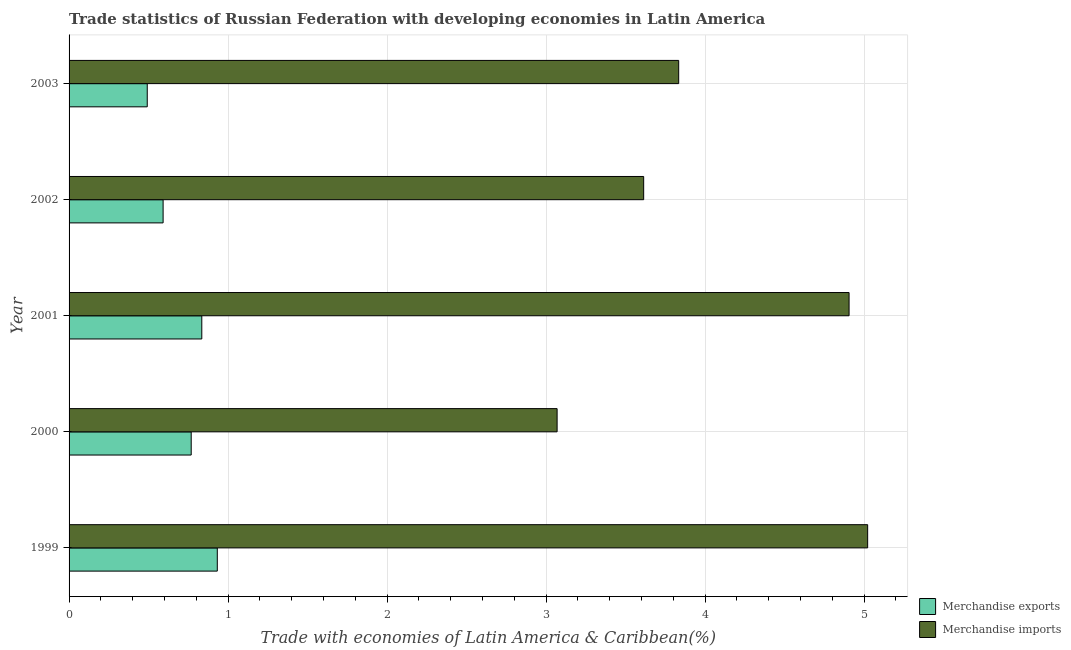How many different coloured bars are there?
Ensure brevity in your answer.  2. How many groups of bars are there?
Ensure brevity in your answer.  5. Are the number of bars per tick equal to the number of legend labels?
Offer a very short reply. Yes. How many bars are there on the 5th tick from the bottom?
Make the answer very short. 2. In how many cases, is the number of bars for a given year not equal to the number of legend labels?
Ensure brevity in your answer.  0. What is the merchandise exports in 2000?
Ensure brevity in your answer.  0.77. Across all years, what is the maximum merchandise imports?
Offer a terse response. 5.02. Across all years, what is the minimum merchandise exports?
Keep it short and to the point. 0.49. In which year was the merchandise exports maximum?
Your answer should be compact. 1999. What is the total merchandise exports in the graph?
Offer a terse response. 3.62. What is the difference between the merchandise imports in 1999 and that in 2003?
Give a very brief answer. 1.19. What is the difference between the merchandise imports in 1999 and the merchandise exports in 2003?
Keep it short and to the point. 4.53. What is the average merchandise exports per year?
Keep it short and to the point. 0.72. In the year 2000, what is the difference between the merchandise exports and merchandise imports?
Offer a terse response. -2.3. In how many years, is the merchandise exports greater than 2.6 %?
Keep it short and to the point. 0. What is the ratio of the merchandise imports in 2000 to that in 2003?
Offer a terse response. 0.8. Is the difference between the merchandise imports in 2000 and 2003 greater than the difference between the merchandise exports in 2000 and 2003?
Keep it short and to the point. No. What is the difference between the highest and the second highest merchandise imports?
Provide a succinct answer. 0.12. What is the difference between the highest and the lowest merchandise imports?
Your answer should be very brief. 1.95. In how many years, is the merchandise imports greater than the average merchandise imports taken over all years?
Your answer should be compact. 2. How many bars are there?
Your response must be concise. 10. Are the values on the major ticks of X-axis written in scientific E-notation?
Keep it short and to the point. No. Where does the legend appear in the graph?
Offer a very short reply. Bottom right. How many legend labels are there?
Provide a succinct answer. 2. How are the legend labels stacked?
Keep it short and to the point. Vertical. What is the title of the graph?
Give a very brief answer. Trade statistics of Russian Federation with developing economies in Latin America. Does "Private credit bureau" appear as one of the legend labels in the graph?
Ensure brevity in your answer.  No. What is the label or title of the X-axis?
Your response must be concise. Trade with economies of Latin America & Caribbean(%). What is the Trade with economies of Latin America & Caribbean(%) of Merchandise exports in 1999?
Give a very brief answer. 0.93. What is the Trade with economies of Latin America & Caribbean(%) of Merchandise imports in 1999?
Make the answer very short. 5.02. What is the Trade with economies of Latin America & Caribbean(%) in Merchandise exports in 2000?
Offer a terse response. 0.77. What is the Trade with economies of Latin America & Caribbean(%) in Merchandise imports in 2000?
Your answer should be compact. 3.07. What is the Trade with economies of Latin America & Caribbean(%) in Merchandise exports in 2001?
Give a very brief answer. 0.83. What is the Trade with economies of Latin America & Caribbean(%) of Merchandise imports in 2001?
Your answer should be very brief. 4.91. What is the Trade with economies of Latin America & Caribbean(%) in Merchandise exports in 2002?
Make the answer very short. 0.59. What is the Trade with economies of Latin America & Caribbean(%) in Merchandise imports in 2002?
Ensure brevity in your answer.  3.61. What is the Trade with economies of Latin America & Caribbean(%) in Merchandise exports in 2003?
Your answer should be very brief. 0.49. What is the Trade with economies of Latin America & Caribbean(%) in Merchandise imports in 2003?
Ensure brevity in your answer.  3.83. Across all years, what is the maximum Trade with economies of Latin America & Caribbean(%) of Merchandise exports?
Give a very brief answer. 0.93. Across all years, what is the maximum Trade with economies of Latin America & Caribbean(%) in Merchandise imports?
Ensure brevity in your answer.  5.02. Across all years, what is the minimum Trade with economies of Latin America & Caribbean(%) in Merchandise exports?
Offer a very short reply. 0.49. Across all years, what is the minimum Trade with economies of Latin America & Caribbean(%) of Merchandise imports?
Your answer should be very brief. 3.07. What is the total Trade with economies of Latin America & Caribbean(%) of Merchandise exports in the graph?
Provide a short and direct response. 3.62. What is the total Trade with economies of Latin America & Caribbean(%) of Merchandise imports in the graph?
Your response must be concise. 20.45. What is the difference between the Trade with economies of Latin America & Caribbean(%) of Merchandise exports in 1999 and that in 2000?
Your answer should be compact. 0.16. What is the difference between the Trade with economies of Latin America & Caribbean(%) of Merchandise imports in 1999 and that in 2000?
Ensure brevity in your answer.  1.95. What is the difference between the Trade with economies of Latin America & Caribbean(%) in Merchandise exports in 1999 and that in 2001?
Provide a succinct answer. 0.1. What is the difference between the Trade with economies of Latin America & Caribbean(%) in Merchandise imports in 1999 and that in 2001?
Offer a very short reply. 0.12. What is the difference between the Trade with economies of Latin America & Caribbean(%) of Merchandise exports in 1999 and that in 2002?
Ensure brevity in your answer.  0.34. What is the difference between the Trade with economies of Latin America & Caribbean(%) of Merchandise imports in 1999 and that in 2002?
Keep it short and to the point. 1.41. What is the difference between the Trade with economies of Latin America & Caribbean(%) in Merchandise exports in 1999 and that in 2003?
Provide a succinct answer. 0.44. What is the difference between the Trade with economies of Latin America & Caribbean(%) of Merchandise imports in 1999 and that in 2003?
Offer a very short reply. 1.19. What is the difference between the Trade with economies of Latin America & Caribbean(%) of Merchandise exports in 2000 and that in 2001?
Make the answer very short. -0.07. What is the difference between the Trade with economies of Latin America & Caribbean(%) in Merchandise imports in 2000 and that in 2001?
Your response must be concise. -1.84. What is the difference between the Trade with economies of Latin America & Caribbean(%) in Merchandise exports in 2000 and that in 2002?
Offer a very short reply. 0.18. What is the difference between the Trade with economies of Latin America & Caribbean(%) of Merchandise imports in 2000 and that in 2002?
Keep it short and to the point. -0.54. What is the difference between the Trade with economies of Latin America & Caribbean(%) of Merchandise exports in 2000 and that in 2003?
Your response must be concise. 0.28. What is the difference between the Trade with economies of Latin America & Caribbean(%) in Merchandise imports in 2000 and that in 2003?
Your response must be concise. -0.76. What is the difference between the Trade with economies of Latin America & Caribbean(%) in Merchandise exports in 2001 and that in 2002?
Ensure brevity in your answer.  0.24. What is the difference between the Trade with economies of Latin America & Caribbean(%) of Merchandise imports in 2001 and that in 2002?
Your answer should be compact. 1.29. What is the difference between the Trade with economies of Latin America & Caribbean(%) of Merchandise exports in 2001 and that in 2003?
Offer a very short reply. 0.34. What is the difference between the Trade with economies of Latin America & Caribbean(%) in Merchandise imports in 2001 and that in 2003?
Offer a very short reply. 1.07. What is the difference between the Trade with economies of Latin America & Caribbean(%) in Merchandise exports in 2002 and that in 2003?
Keep it short and to the point. 0.1. What is the difference between the Trade with economies of Latin America & Caribbean(%) in Merchandise imports in 2002 and that in 2003?
Your answer should be compact. -0.22. What is the difference between the Trade with economies of Latin America & Caribbean(%) of Merchandise exports in 1999 and the Trade with economies of Latin America & Caribbean(%) of Merchandise imports in 2000?
Ensure brevity in your answer.  -2.14. What is the difference between the Trade with economies of Latin America & Caribbean(%) of Merchandise exports in 1999 and the Trade with economies of Latin America & Caribbean(%) of Merchandise imports in 2001?
Provide a short and direct response. -3.97. What is the difference between the Trade with economies of Latin America & Caribbean(%) in Merchandise exports in 1999 and the Trade with economies of Latin America & Caribbean(%) in Merchandise imports in 2002?
Your answer should be very brief. -2.68. What is the difference between the Trade with economies of Latin America & Caribbean(%) of Merchandise exports in 1999 and the Trade with economies of Latin America & Caribbean(%) of Merchandise imports in 2003?
Provide a short and direct response. -2.9. What is the difference between the Trade with economies of Latin America & Caribbean(%) of Merchandise exports in 2000 and the Trade with economies of Latin America & Caribbean(%) of Merchandise imports in 2001?
Give a very brief answer. -4.14. What is the difference between the Trade with economies of Latin America & Caribbean(%) in Merchandise exports in 2000 and the Trade with economies of Latin America & Caribbean(%) in Merchandise imports in 2002?
Your answer should be very brief. -2.85. What is the difference between the Trade with economies of Latin America & Caribbean(%) of Merchandise exports in 2000 and the Trade with economies of Latin America & Caribbean(%) of Merchandise imports in 2003?
Ensure brevity in your answer.  -3.07. What is the difference between the Trade with economies of Latin America & Caribbean(%) of Merchandise exports in 2001 and the Trade with economies of Latin America & Caribbean(%) of Merchandise imports in 2002?
Make the answer very short. -2.78. What is the difference between the Trade with economies of Latin America & Caribbean(%) in Merchandise exports in 2001 and the Trade with economies of Latin America & Caribbean(%) in Merchandise imports in 2003?
Offer a very short reply. -3. What is the difference between the Trade with economies of Latin America & Caribbean(%) of Merchandise exports in 2002 and the Trade with economies of Latin America & Caribbean(%) of Merchandise imports in 2003?
Provide a succinct answer. -3.24. What is the average Trade with economies of Latin America & Caribbean(%) of Merchandise exports per year?
Make the answer very short. 0.72. What is the average Trade with economies of Latin America & Caribbean(%) of Merchandise imports per year?
Keep it short and to the point. 4.09. In the year 1999, what is the difference between the Trade with economies of Latin America & Caribbean(%) in Merchandise exports and Trade with economies of Latin America & Caribbean(%) in Merchandise imports?
Provide a succinct answer. -4.09. In the year 2000, what is the difference between the Trade with economies of Latin America & Caribbean(%) in Merchandise exports and Trade with economies of Latin America & Caribbean(%) in Merchandise imports?
Ensure brevity in your answer.  -2.3. In the year 2001, what is the difference between the Trade with economies of Latin America & Caribbean(%) in Merchandise exports and Trade with economies of Latin America & Caribbean(%) in Merchandise imports?
Keep it short and to the point. -4.07. In the year 2002, what is the difference between the Trade with economies of Latin America & Caribbean(%) in Merchandise exports and Trade with economies of Latin America & Caribbean(%) in Merchandise imports?
Your answer should be very brief. -3.02. In the year 2003, what is the difference between the Trade with economies of Latin America & Caribbean(%) of Merchandise exports and Trade with economies of Latin America & Caribbean(%) of Merchandise imports?
Your answer should be very brief. -3.34. What is the ratio of the Trade with economies of Latin America & Caribbean(%) in Merchandise exports in 1999 to that in 2000?
Your response must be concise. 1.21. What is the ratio of the Trade with economies of Latin America & Caribbean(%) of Merchandise imports in 1999 to that in 2000?
Your answer should be very brief. 1.64. What is the ratio of the Trade with economies of Latin America & Caribbean(%) in Merchandise exports in 1999 to that in 2001?
Provide a succinct answer. 1.12. What is the ratio of the Trade with economies of Latin America & Caribbean(%) of Merchandise imports in 1999 to that in 2001?
Keep it short and to the point. 1.02. What is the ratio of the Trade with economies of Latin America & Caribbean(%) in Merchandise exports in 1999 to that in 2002?
Ensure brevity in your answer.  1.58. What is the ratio of the Trade with economies of Latin America & Caribbean(%) in Merchandise imports in 1999 to that in 2002?
Your response must be concise. 1.39. What is the ratio of the Trade with economies of Latin America & Caribbean(%) of Merchandise exports in 1999 to that in 2003?
Make the answer very short. 1.9. What is the ratio of the Trade with economies of Latin America & Caribbean(%) of Merchandise imports in 1999 to that in 2003?
Provide a succinct answer. 1.31. What is the ratio of the Trade with economies of Latin America & Caribbean(%) of Merchandise exports in 2000 to that in 2001?
Your answer should be compact. 0.92. What is the ratio of the Trade with economies of Latin America & Caribbean(%) of Merchandise imports in 2000 to that in 2001?
Your answer should be compact. 0.63. What is the ratio of the Trade with economies of Latin America & Caribbean(%) of Merchandise exports in 2000 to that in 2002?
Give a very brief answer. 1.3. What is the ratio of the Trade with economies of Latin America & Caribbean(%) in Merchandise imports in 2000 to that in 2002?
Your response must be concise. 0.85. What is the ratio of the Trade with economies of Latin America & Caribbean(%) of Merchandise exports in 2000 to that in 2003?
Your answer should be compact. 1.56. What is the ratio of the Trade with economies of Latin America & Caribbean(%) in Merchandise imports in 2000 to that in 2003?
Offer a very short reply. 0.8. What is the ratio of the Trade with economies of Latin America & Caribbean(%) in Merchandise exports in 2001 to that in 2002?
Provide a short and direct response. 1.41. What is the ratio of the Trade with economies of Latin America & Caribbean(%) of Merchandise imports in 2001 to that in 2002?
Make the answer very short. 1.36. What is the ratio of the Trade with economies of Latin America & Caribbean(%) in Merchandise exports in 2001 to that in 2003?
Make the answer very short. 1.7. What is the ratio of the Trade with economies of Latin America & Caribbean(%) in Merchandise imports in 2001 to that in 2003?
Provide a short and direct response. 1.28. What is the ratio of the Trade with economies of Latin America & Caribbean(%) of Merchandise exports in 2002 to that in 2003?
Keep it short and to the point. 1.2. What is the ratio of the Trade with economies of Latin America & Caribbean(%) of Merchandise imports in 2002 to that in 2003?
Your answer should be compact. 0.94. What is the difference between the highest and the second highest Trade with economies of Latin America & Caribbean(%) in Merchandise exports?
Give a very brief answer. 0.1. What is the difference between the highest and the second highest Trade with economies of Latin America & Caribbean(%) of Merchandise imports?
Provide a succinct answer. 0.12. What is the difference between the highest and the lowest Trade with economies of Latin America & Caribbean(%) of Merchandise exports?
Keep it short and to the point. 0.44. What is the difference between the highest and the lowest Trade with economies of Latin America & Caribbean(%) of Merchandise imports?
Your response must be concise. 1.95. 